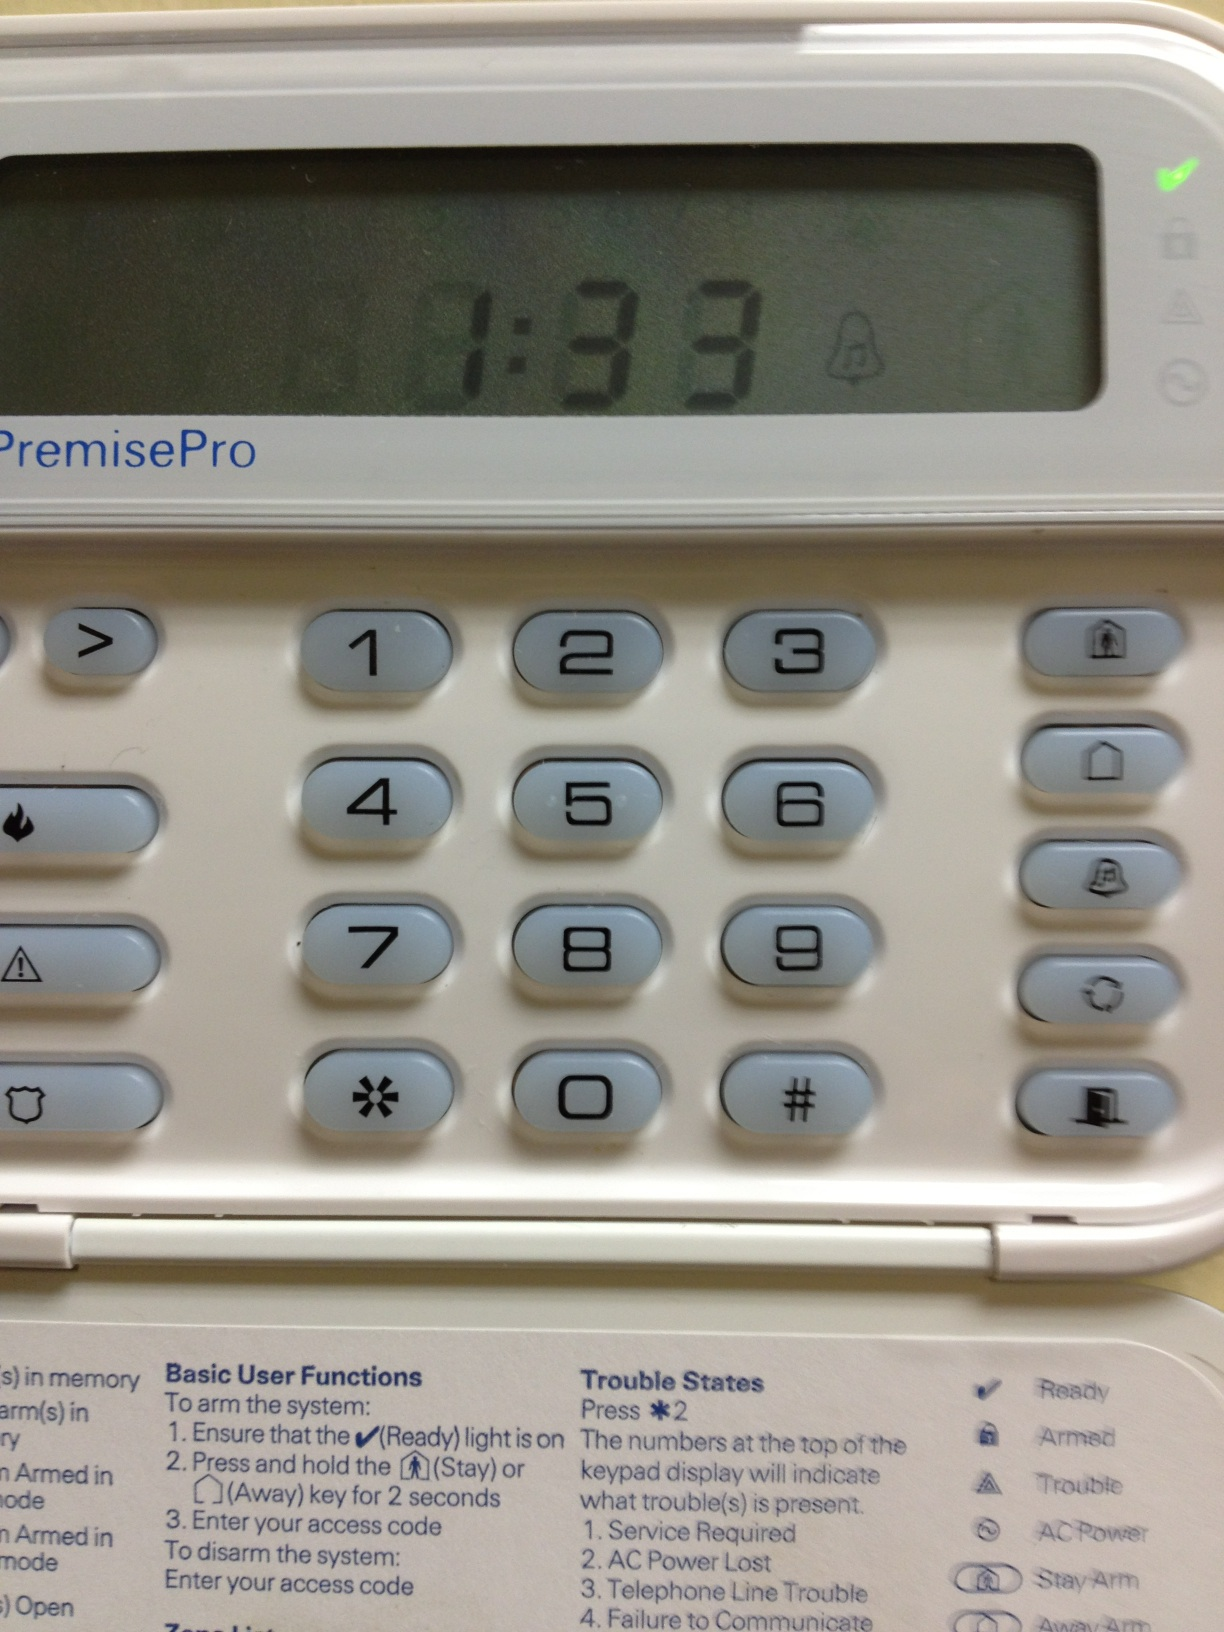It seems like there's a time displayed; can this keypad also function as a clock? Yes, the time display likely indicates that this security system keypad also serves the dual function of a clock, keeping the user informed of the current time as well as managing security settings. 